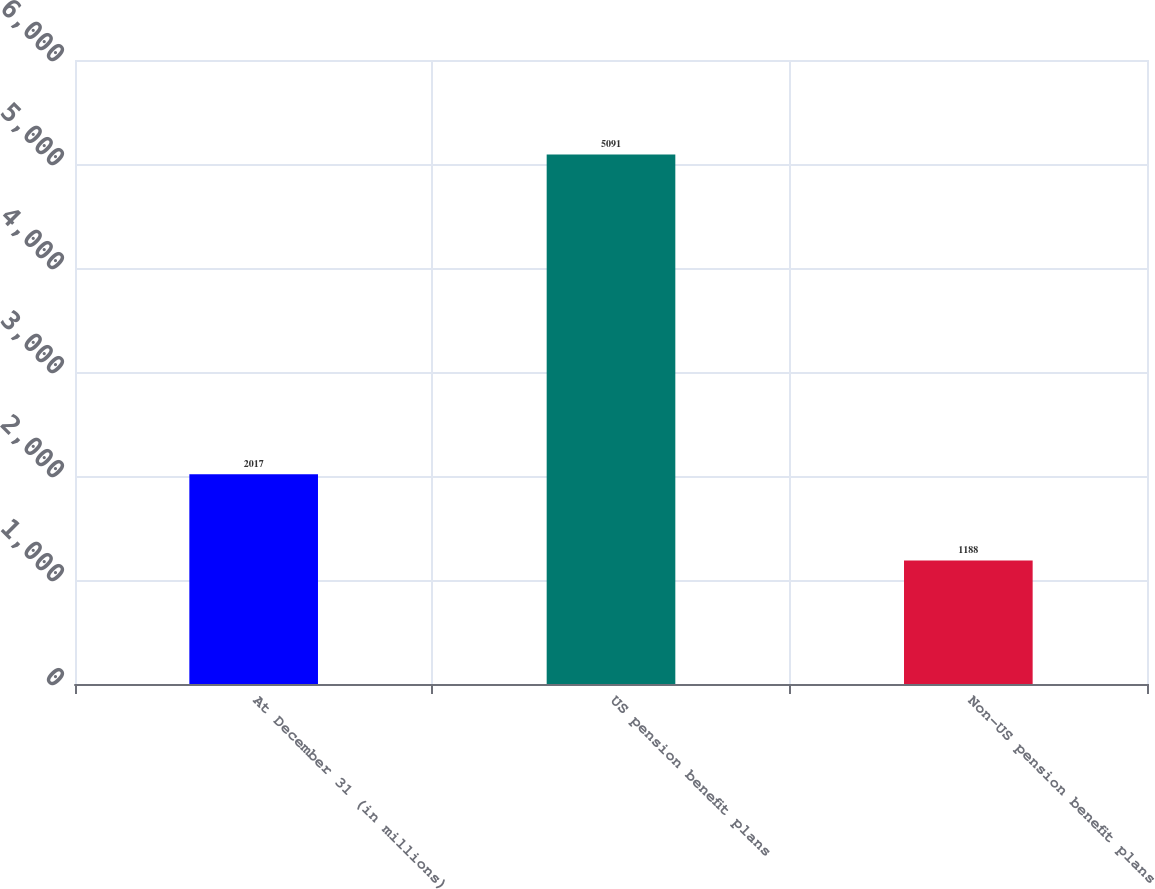<chart> <loc_0><loc_0><loc_500><loc_500><bar_chart><fcel>At December 31 (in millions)<fcel>US pension benefit plans<fcel>Non-US pension benefit plans<nl><fcel>2017<fcel>5091<fcel>1188<nl></chart> 